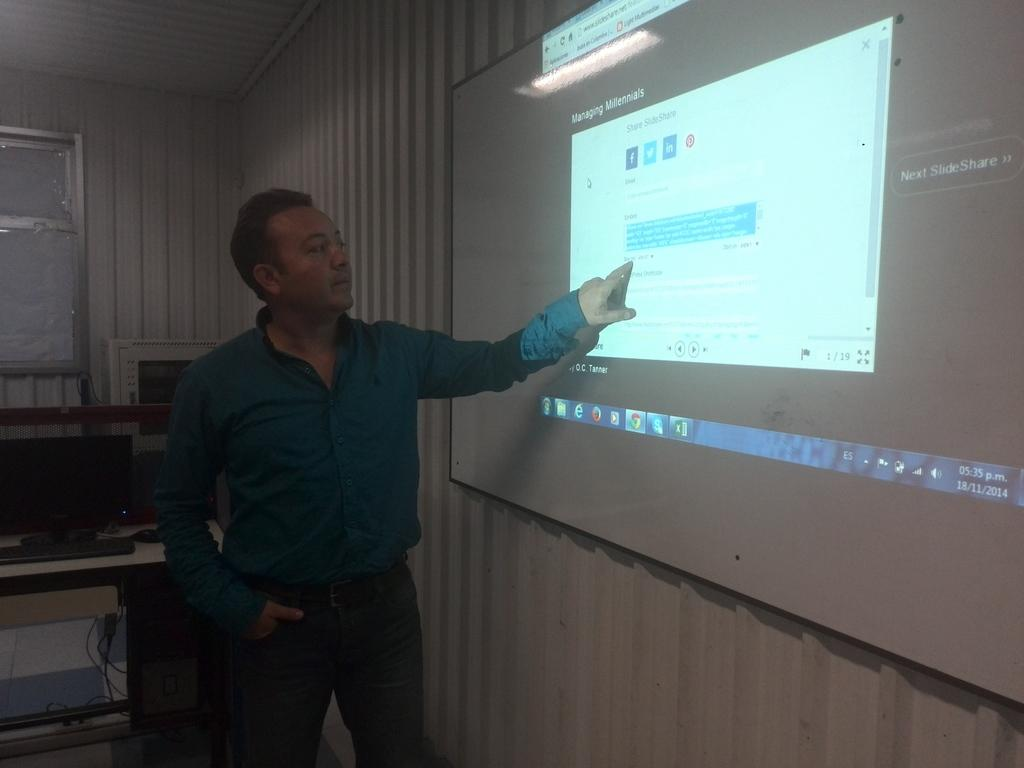<image>
Present a compact description of the photo's key features. Man pointing at screen projection of A PC screen. 